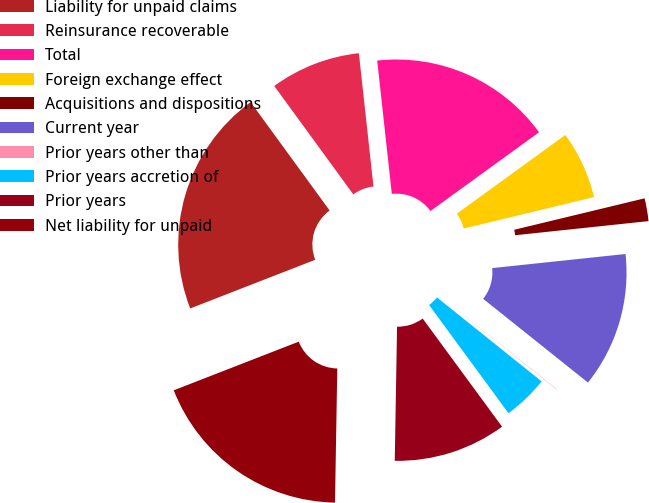Convert chart to OTSL. <chart><loc_0><loc_0><loc_500><loc_500><pie_chart><fcel>Liability for unpaid claims<fcel>Reinsurance recoverable<fcel>Total<fcel>Foreign exchange effect<fcel>Acquisitions and dispositions<fcel>Current year<fcel>Prior years other than<fcel>Prior years accretion of<fcel>Prior years<fcel>Net liability for unpaid<nl><fcel>20.88%<fcel>8.29%<fcel>16.75%<fcel>6.22%<fcel>2.09%<fcel>12.41%<fcel>0.03%<fcel>4.16%<fcel>10.35%<fcel>18.82%<nl></chart> 